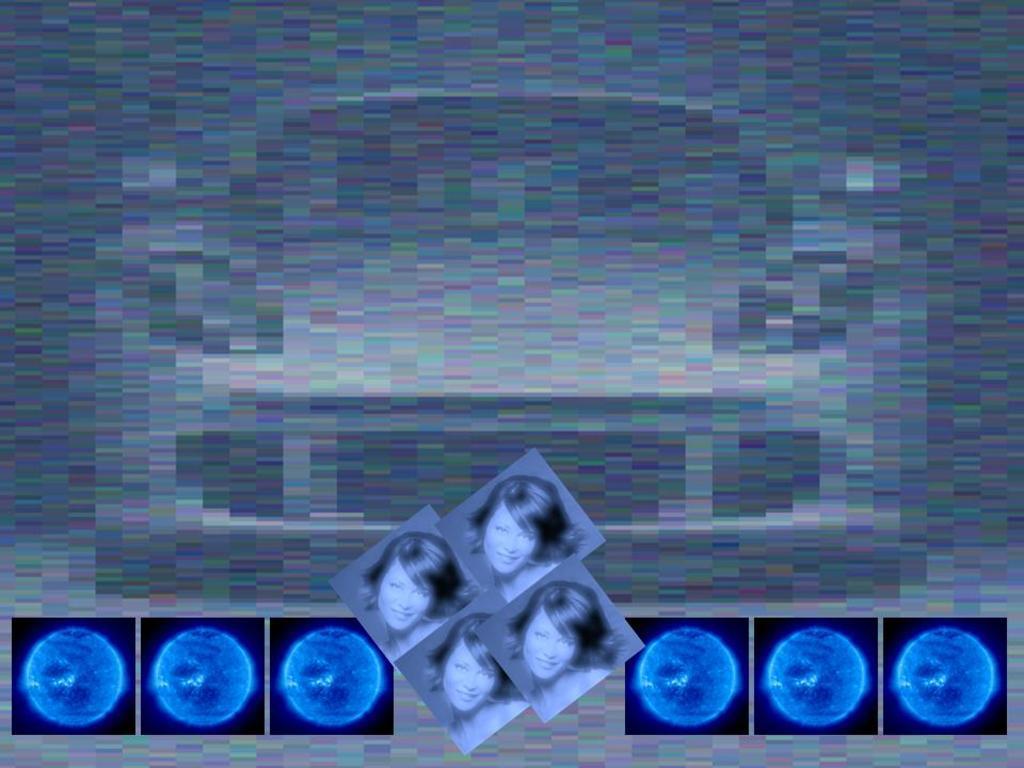Could you give a brief overview of what you see in this image? In this image I can see few depiction pictures of a woman and of few blue color things. I can also this image is little bit blurry. 